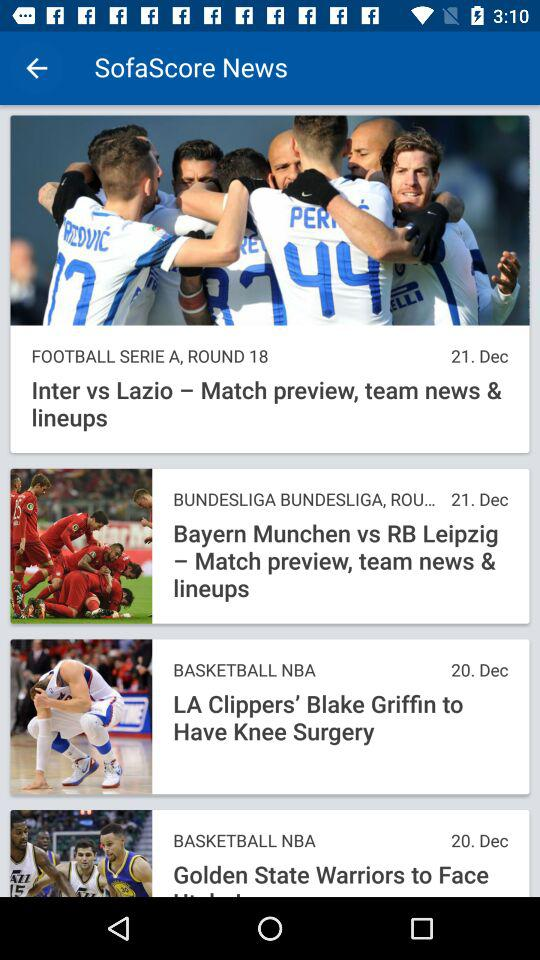On what date was the news about the match between "Inter" and "Lazio" posted? The news about the match between "Inter" and "Lazio" was posted on December 21. 